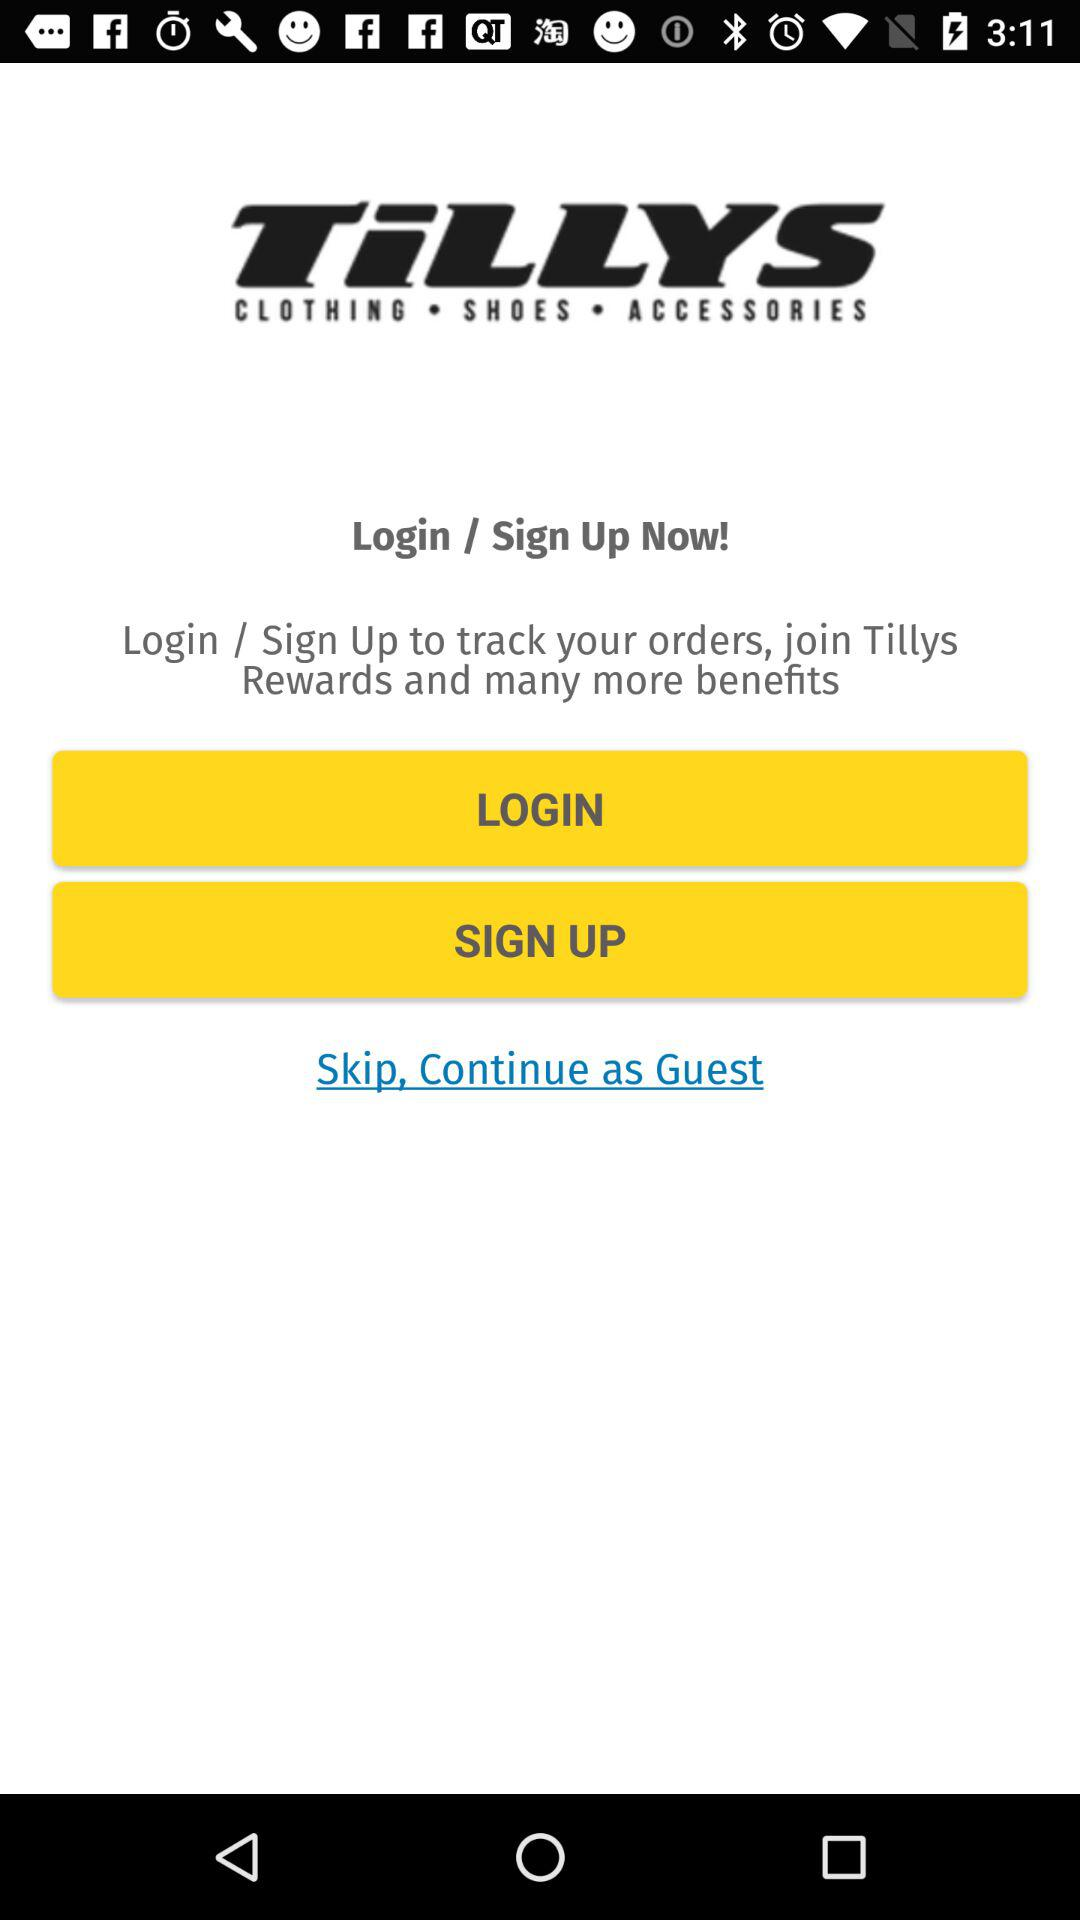What is the name of the application? The name of the application is "TiLLYS". 